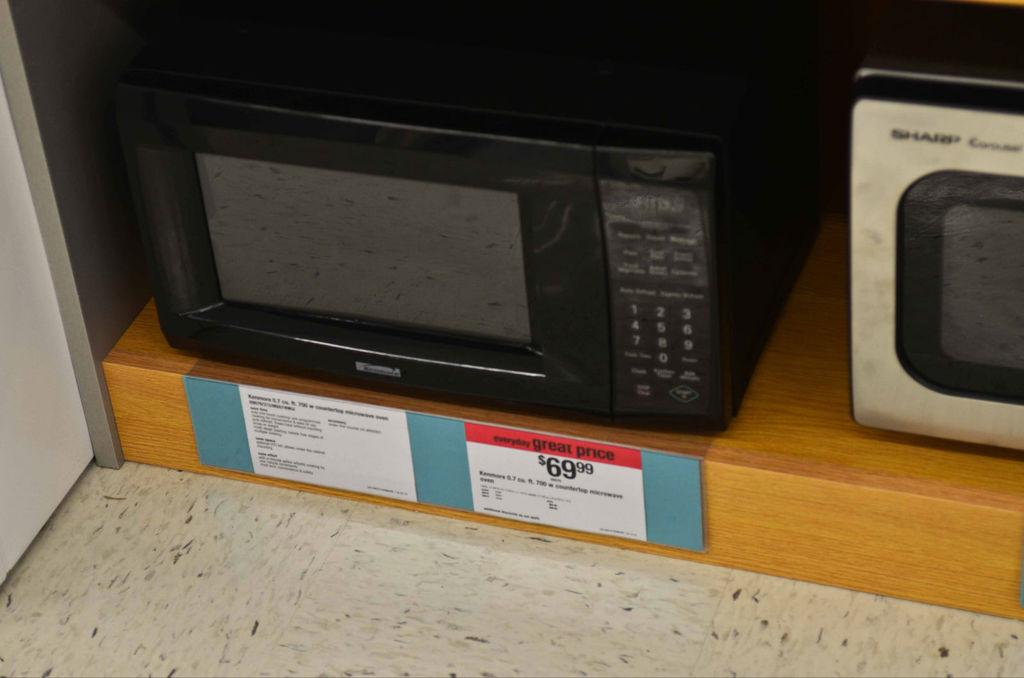<image>
Present a compact description of the photo's key features. A microwave oven that is advertised for having the great price of $69.99. 